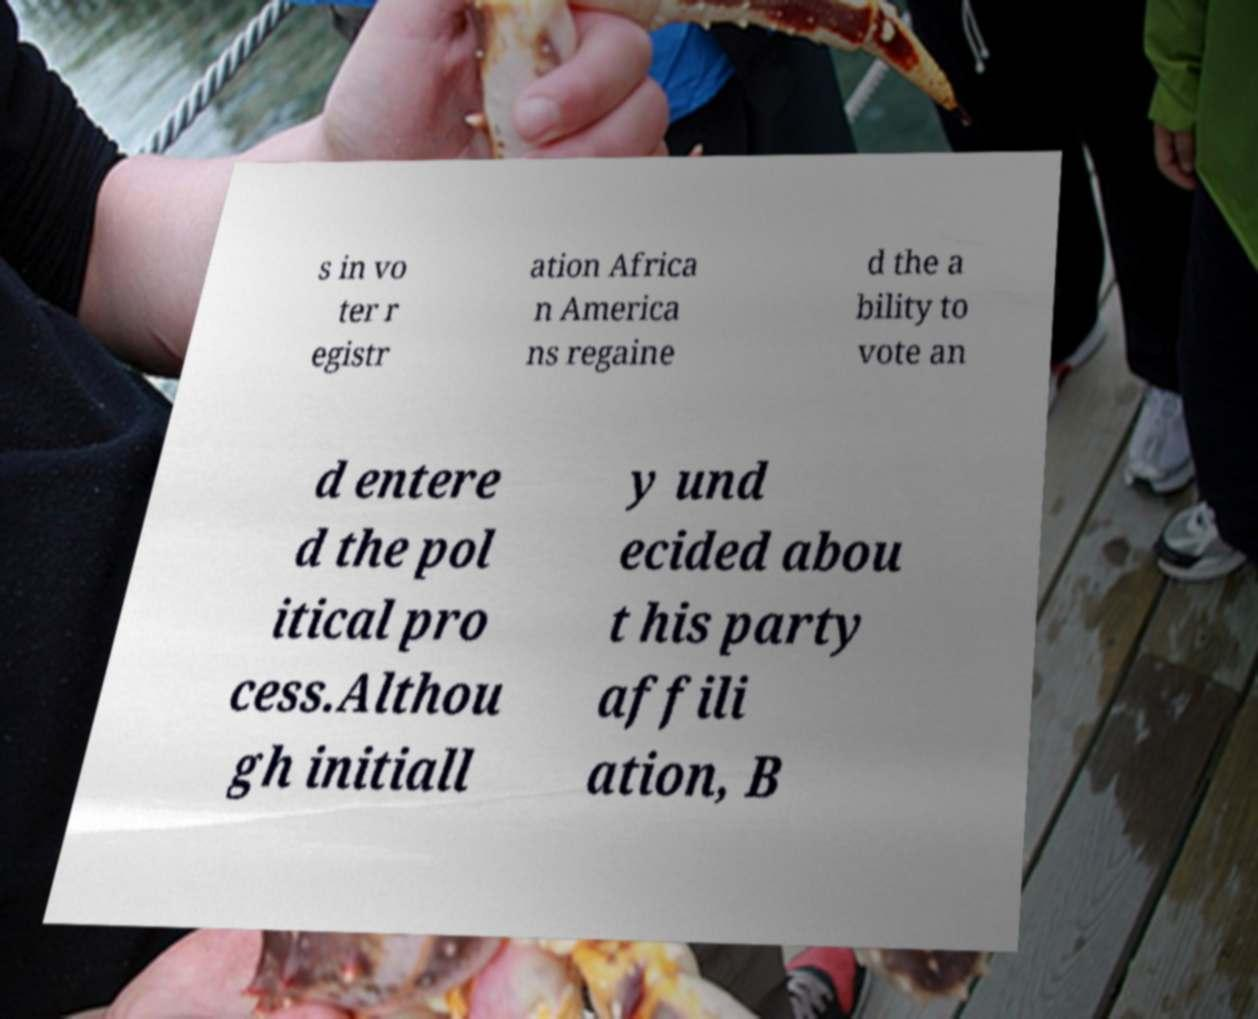Could you assist in decoding the text presented in this image and type it out clearly? s in vo ter r egistr ation Africa n America ns regaine d the a bility to vote an d entere d the pol itical pro cess.Althou gh initiall y und ecided abou t his party affili ation, B 